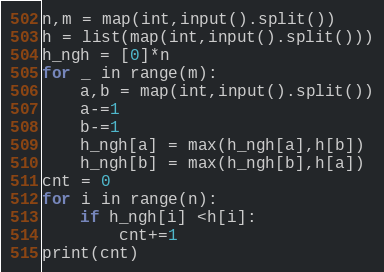Convert code to text. <code><loc_0><loc_0><loc_500><loc_500><_Python_>n,m = map(int,input().split())
h = list(map(int,input().split()))
h_ngh = [0]*n
for _ in range(m):
    a,b = map(int,input().split())
    a-=1
    b-=1
    h_ngh[a] = max(h_ngh[a],h[b])
    h_ngh[b] = max(h_ngh[b],h[a])
cnt = 0
for i in range(n):
    if h_ngh[i] <h[i]:
        cnt+=1
print(cnt)</code> 